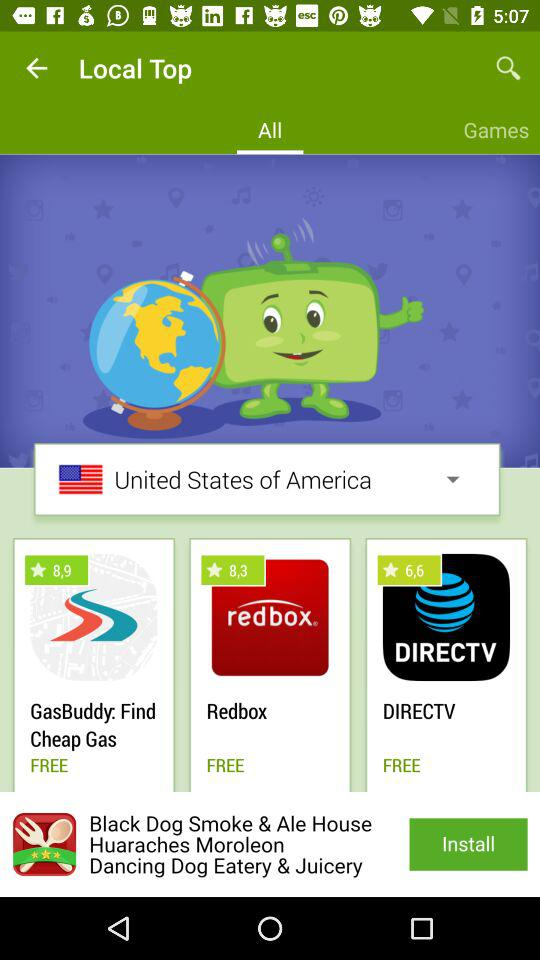Which country is selected? The selected country is the United States of America. 